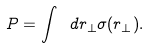Convert formula to latex. <formula><loc_0><loc_0><loc_500><loc_500>P = \int \ d r _ { \perp } \sigma ( r _ { \perp } ) .</formula> 